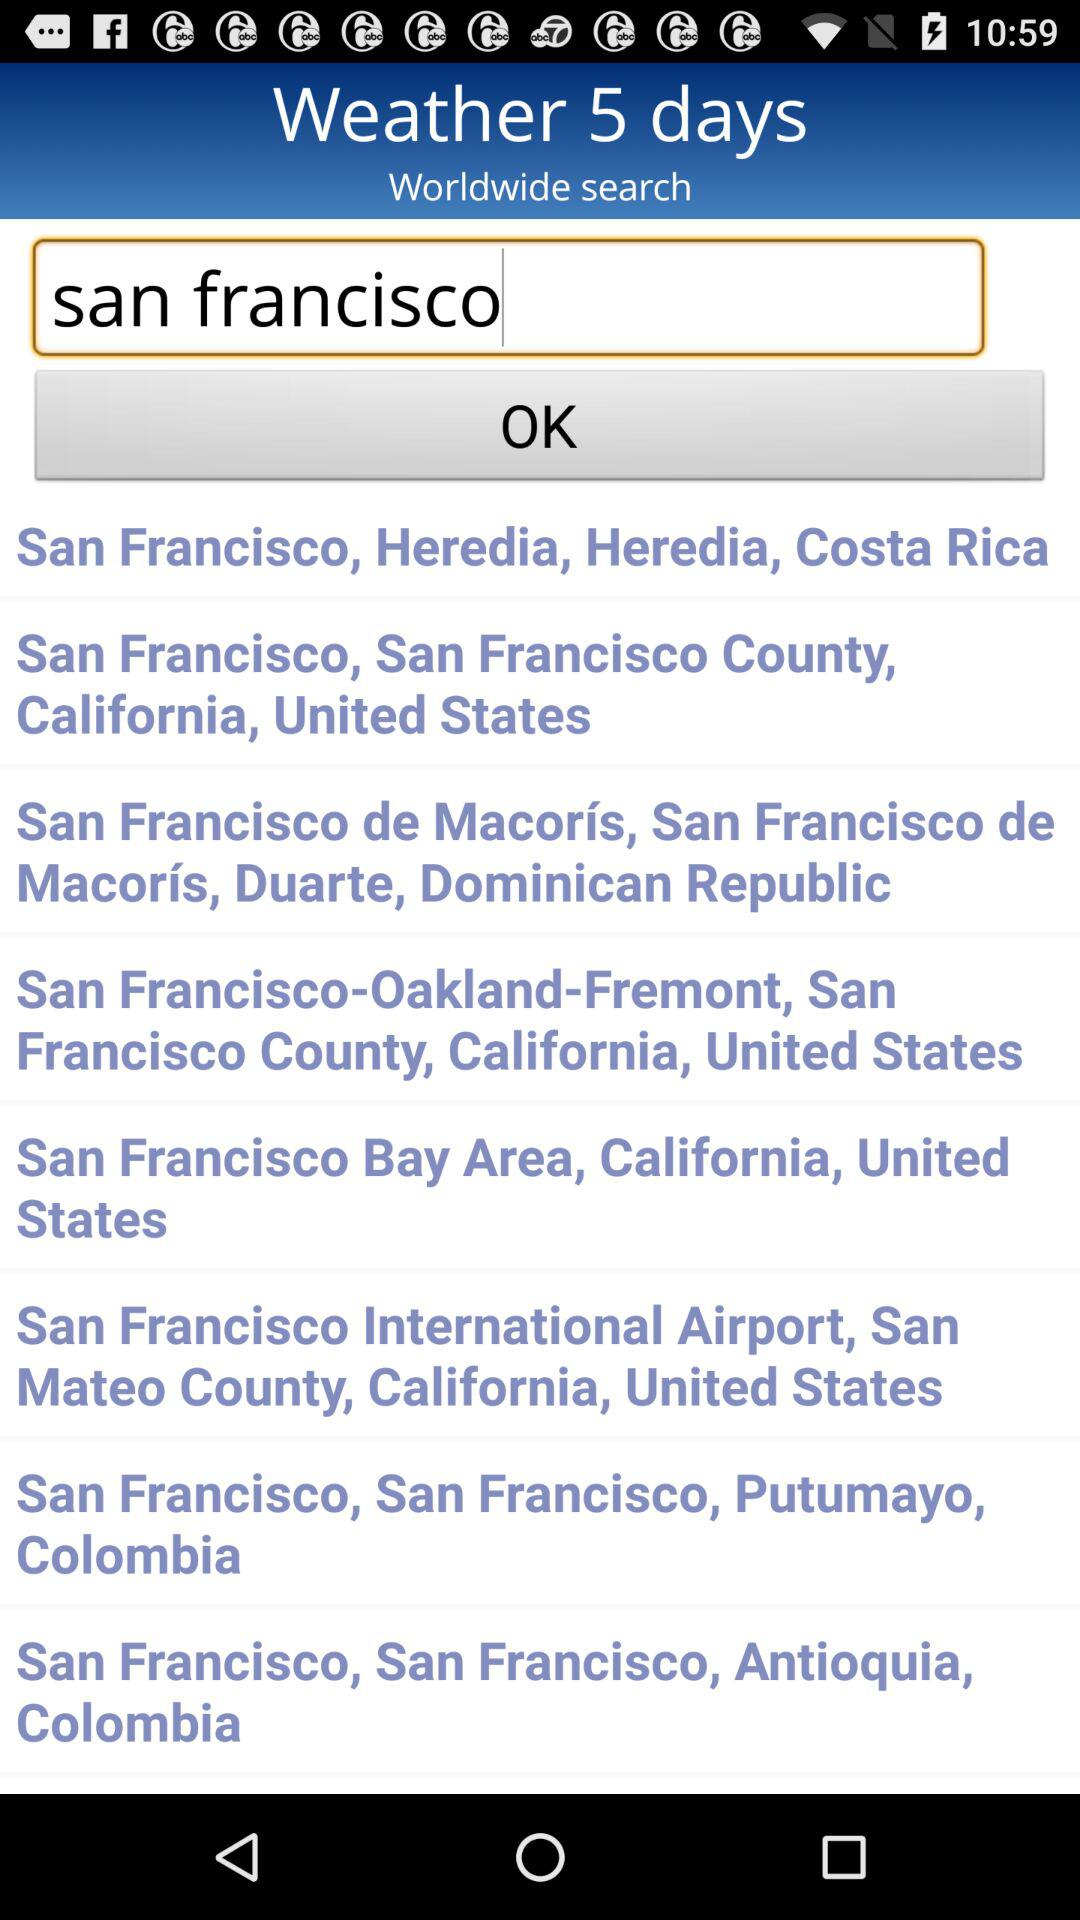What is the text written in the text field? The text written in the text field is "san francisco". 